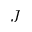<formula> <loc_0><loc_0><loc_500><loc_500>J</formula> 